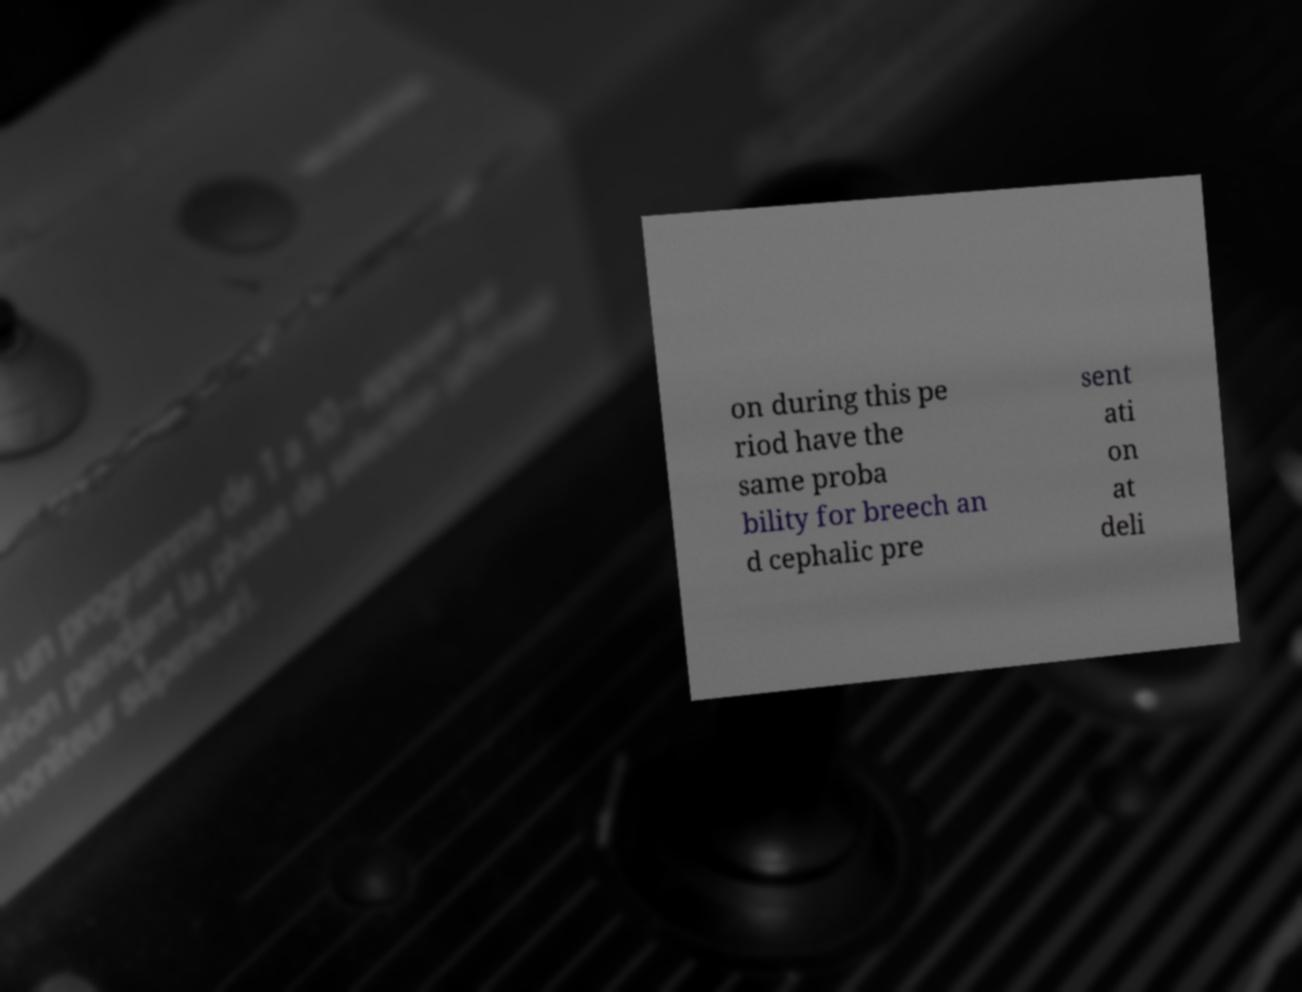Please read and relay the text visible in this image. What does it say? on during this pe riod have the same proba bility for breech an d cephalic pre sent ati on at deli 